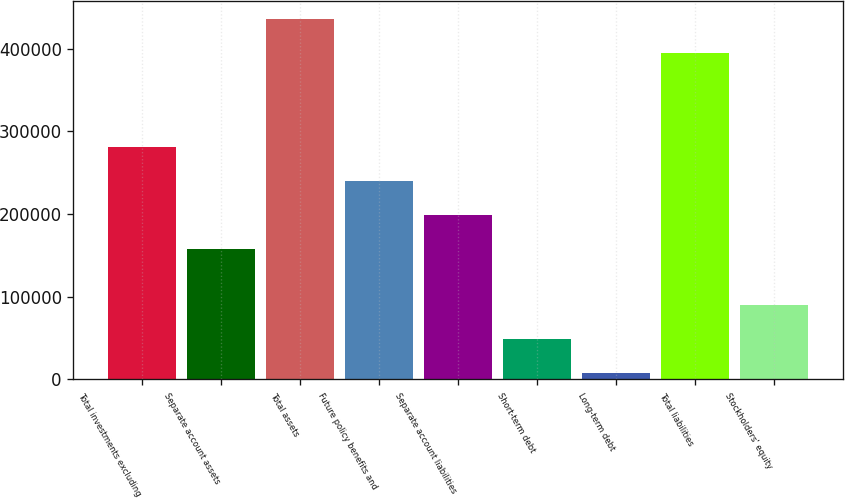Convert chart to OTSL. <chart><loc_0><loc_0><loc_500><loc_500><bar_chart><fcel>Total investments excluding<fcel>Separate account assets<fcel>Total assets<fcel>Future policy benefits and<fcel>Separate account liabilities<fcel>Short-term debt<fcel>Long-term debt<fcel>Total liabilities<fcel>Stockholders' equity<nl><fcel>280413<fcel>157561<fcel>435964<fcel>239462<fcel>198512<fcel>49220.6<fcel>8270<fcel>395013<fcel>90171.2<nl></chart> 